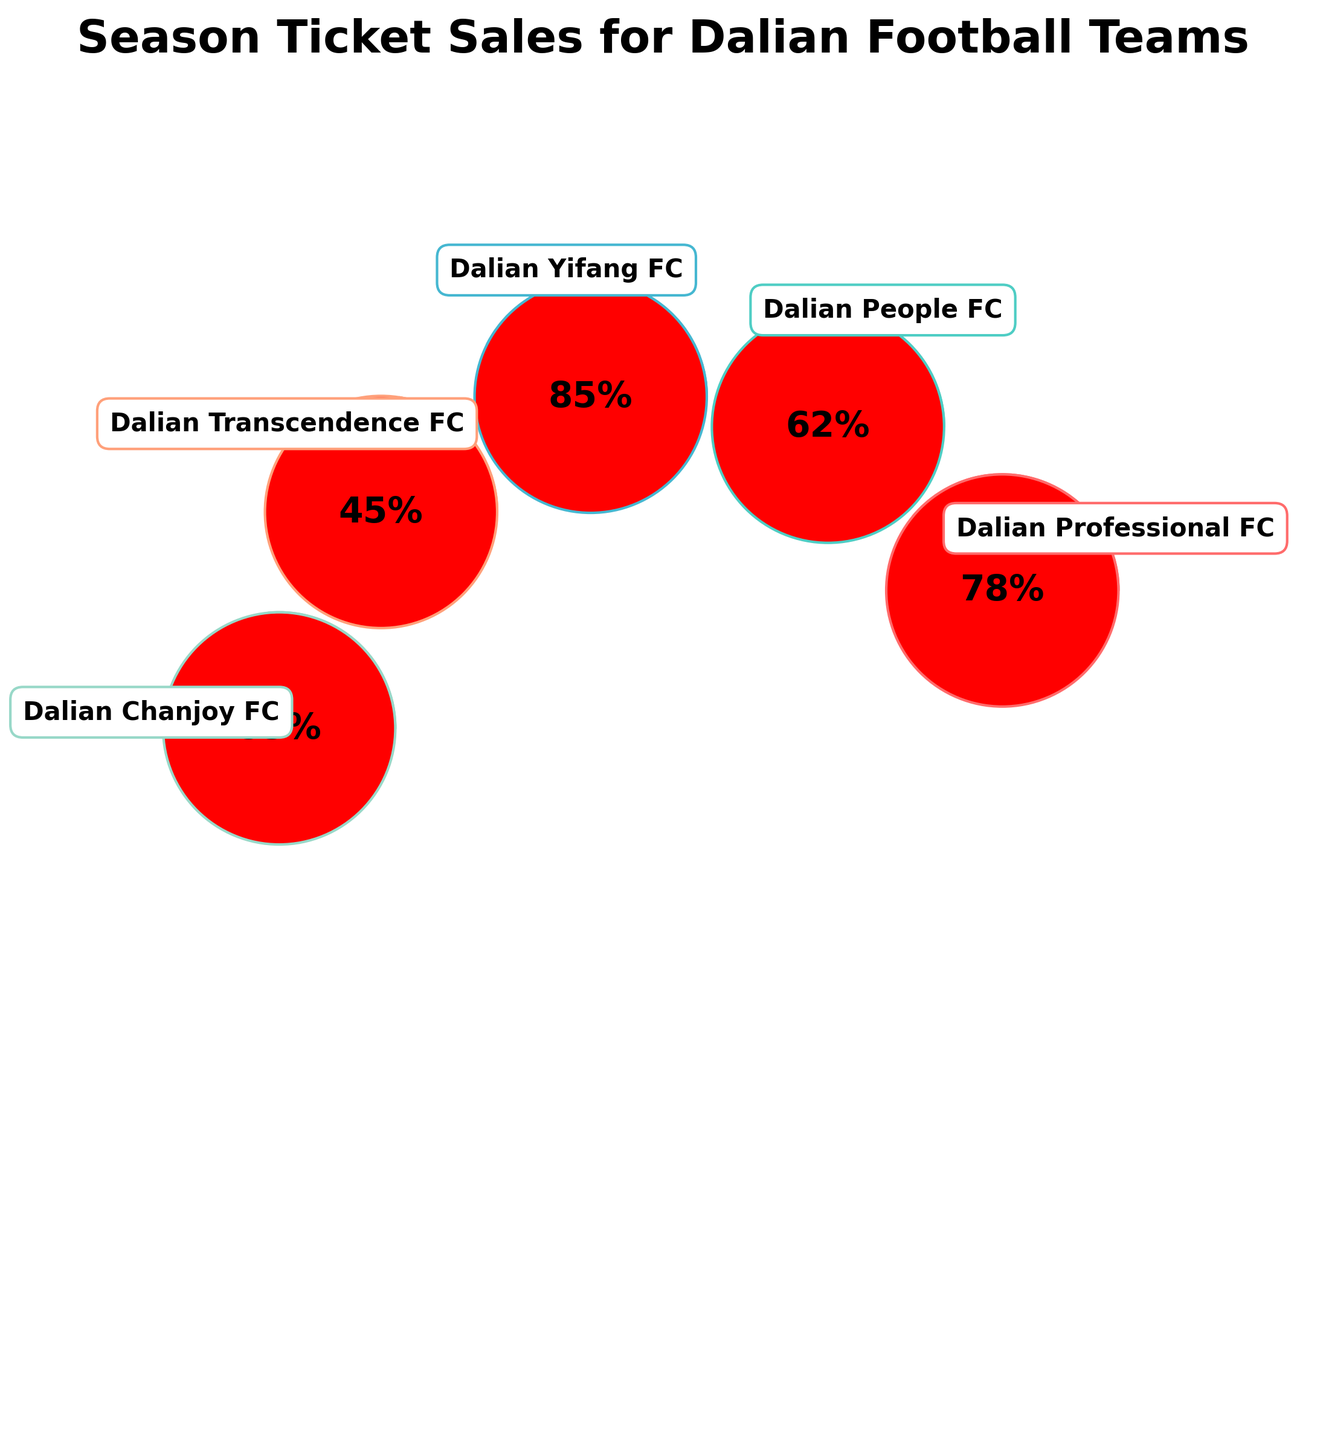What's the team with the highest percentage of season ticket sales achieved? By looking at the plot and observing the percentages listed for each team, we can see that Dalian Yifang FC has the highest percentage at 85%.
Answer: Dalian Yifang FC What's the difference in percentage of season ticket sales between Dalian Professional FC and Dalian Transcendence FC? The percentage for Dalian Professional FC is 78%, and for Dalian Transcendence FC is 45%. Subtract 45 from 78 to get the difference: 78 - 45 = 33.
Answer: 33% Which Dalian football team has achieved less than 50% of season ticket sales? By observing all the percentages, we find that Dalian Transcendence FC has achieved 45%, which is less than 50%.
Answer: Dalian Transcendence FC How many teams have achieved more than 60% of their season ticket sales? From the percentages given: 78%, 62%, 85%, 45%, and 53%, we identify four teams that have more than 60%: Dalian Professional FC, Dalian People FC, and Dalian Yifang FC.
Answer: 3 teams What's the average percentage of season ticket sales achieved by all Dalian football teams? Add all percentages: 78 + 62 + 85 + 45 + 53 = 323. There are 5 teams, so divide 323 by 5 to get the average: 323 / 5 = 64.6%.
Answer: 64.6% Is the percentage of season ticket sales for Dalian Chanjoy FC greater than that for Dalian People FC? By comparing the percentages, Dalian Chanjoy FC has 53%, and Dalian People FC has 62%. Since 53% is less than 62%, the statement is false.
Answer: No What is the median percentage of season ticket sales achieved by the five teams? First, order the percentages: 45, 53, 62, 78, 85. The middle value (third in the ordered list) is 62%.
Answer: 62% Which team's gauge indicator is the farthest to the left on the plot? The positioning of the gauges is based on their angle, with the first team's left-most. The team on the farthest left is Dalian Professional FC.
Answer: Dalian Professional FC How is the title described in the figure? The title is "Season Ticket Sales for Dalian Football Teams," which is located above the plots, highlighting the main topic of the chart.
Answer: Season Ticket Sales for Dalian Football Teams 